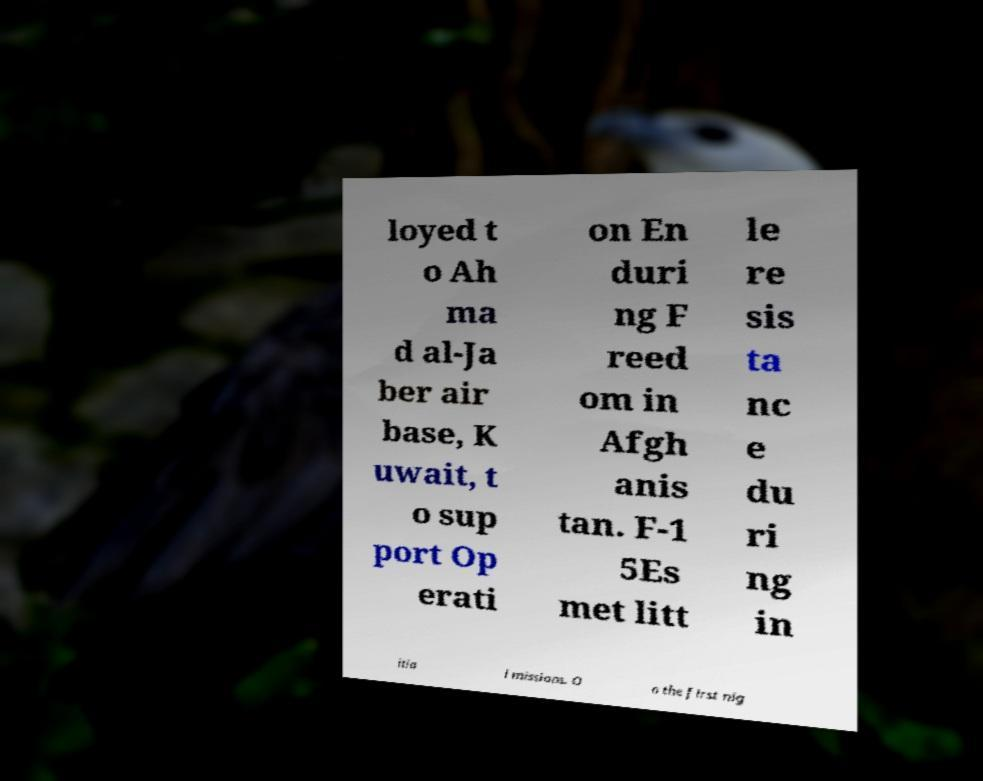What messages or text are displayed in this image? I need them in a readable, typed format. loyed t o Ah ma d al-Ja ber air base, K uwait, t o sup port Op erati on En duri ng F reed om in Afgh anis tan. F-1 5Es met litt le re sis ta nc e du ri ng in itia l missions. O n the first nig 